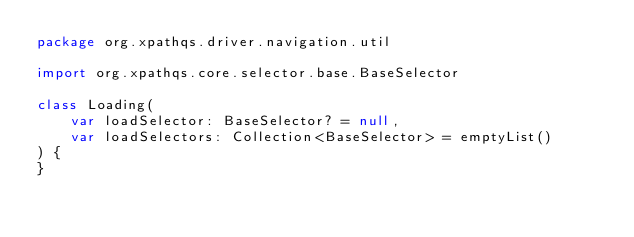<code> <loc_0><loc_0><loc_500><loc_500><_Kotlin_>package org.xpathqs.driver.navigation.util

import org.xpathqs.core.selector.base.BaseSelector

class Loading(
    var loadSelector: BaseSelector? = null,
    var loadSelectors: Collection<BaseSelector> = emptyList()
) {
}</code> 